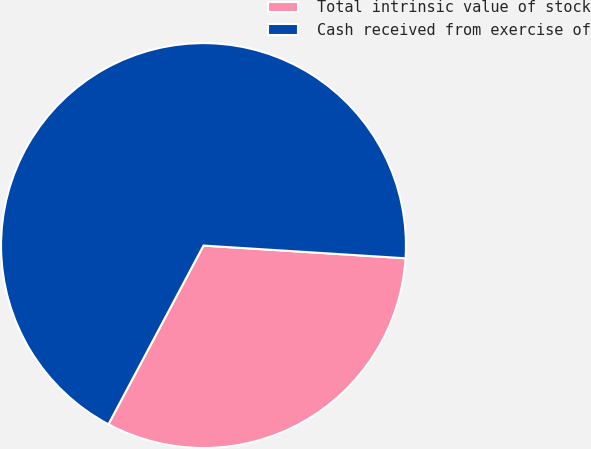Convert chart to OTSL. <chart><loc_0><loc_0><loc_500><loc_500><pie_chart><fcel>Total intrinsic value of stock<fcel>Cash received from exercise of<nl><fcel>31.78%<fcel>68.22%<nl></chart> 